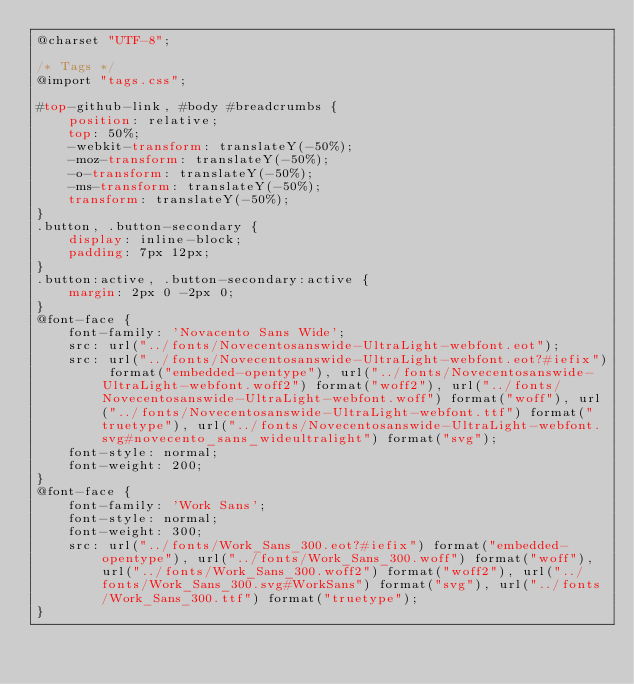<code> <loc_0><loc_0><loc_500><loc_500><_CSS_>@charset "UTF-8";

/* Tags */
@import "tags.css";

#top-github-link, #body #breadcrumbs {
    position: relative;
    top: 50%;
    -webkit-transform: translateY(-50%);
    -moz-transform: translateY(-50%);
    -o-transform: translateY(-50%);
    -ms-transform: translateY(-50%);
    transform: translateY(-50%);
}
.button, .button-secondary {
    display: inline-block;
    padding: 7px 12px;
}
.button:active, .button-secondary:active {
    margin: 2px 0 -2px 0;
}
@font-face {
    font-family: 'Novacento Sans Wide';
    src: url("../fonts/Novecentosanswide-UltraLight-webfont.eot");
    src: url("../fonts/Novecentosanswide-UltraLight-webfont.eot?#iefix") format("embedded-opentype"), url("../fonts/Novecentosanswide-UltraLight-webfont.woff2") format("woff2"), url("../fonts/Novecentosanswide-UltraLight-webfont.woff") format("woff"), url("../fonts/Novecentosanswide-UltraLight-webfont.ttf") format("truetype"), url("../fonts/Novecentosanswide-UltraLight-webfont.svg#novecento_sans_wideultralight") format("svg");
    font-style: normal;
    font-weight: 200;
}
@font-face {
    font-family: 'Work Sans';
    font-style: normal;
    font-weight: 300;
    src: url("../fonts/Work_Sans_300.eot?#iefix") format("embedded-opentype"), url("../fonts/Work_Sans_300.woff") format("woff"), url("../fonts/Work_Sans_300.woff2") format("woff2"), url("../fonts/Work_Sans_300.svg#WorkSans") format("svg"), url("../fonts/Work_Sans_300.ttf") format("truetype");
}</code> 